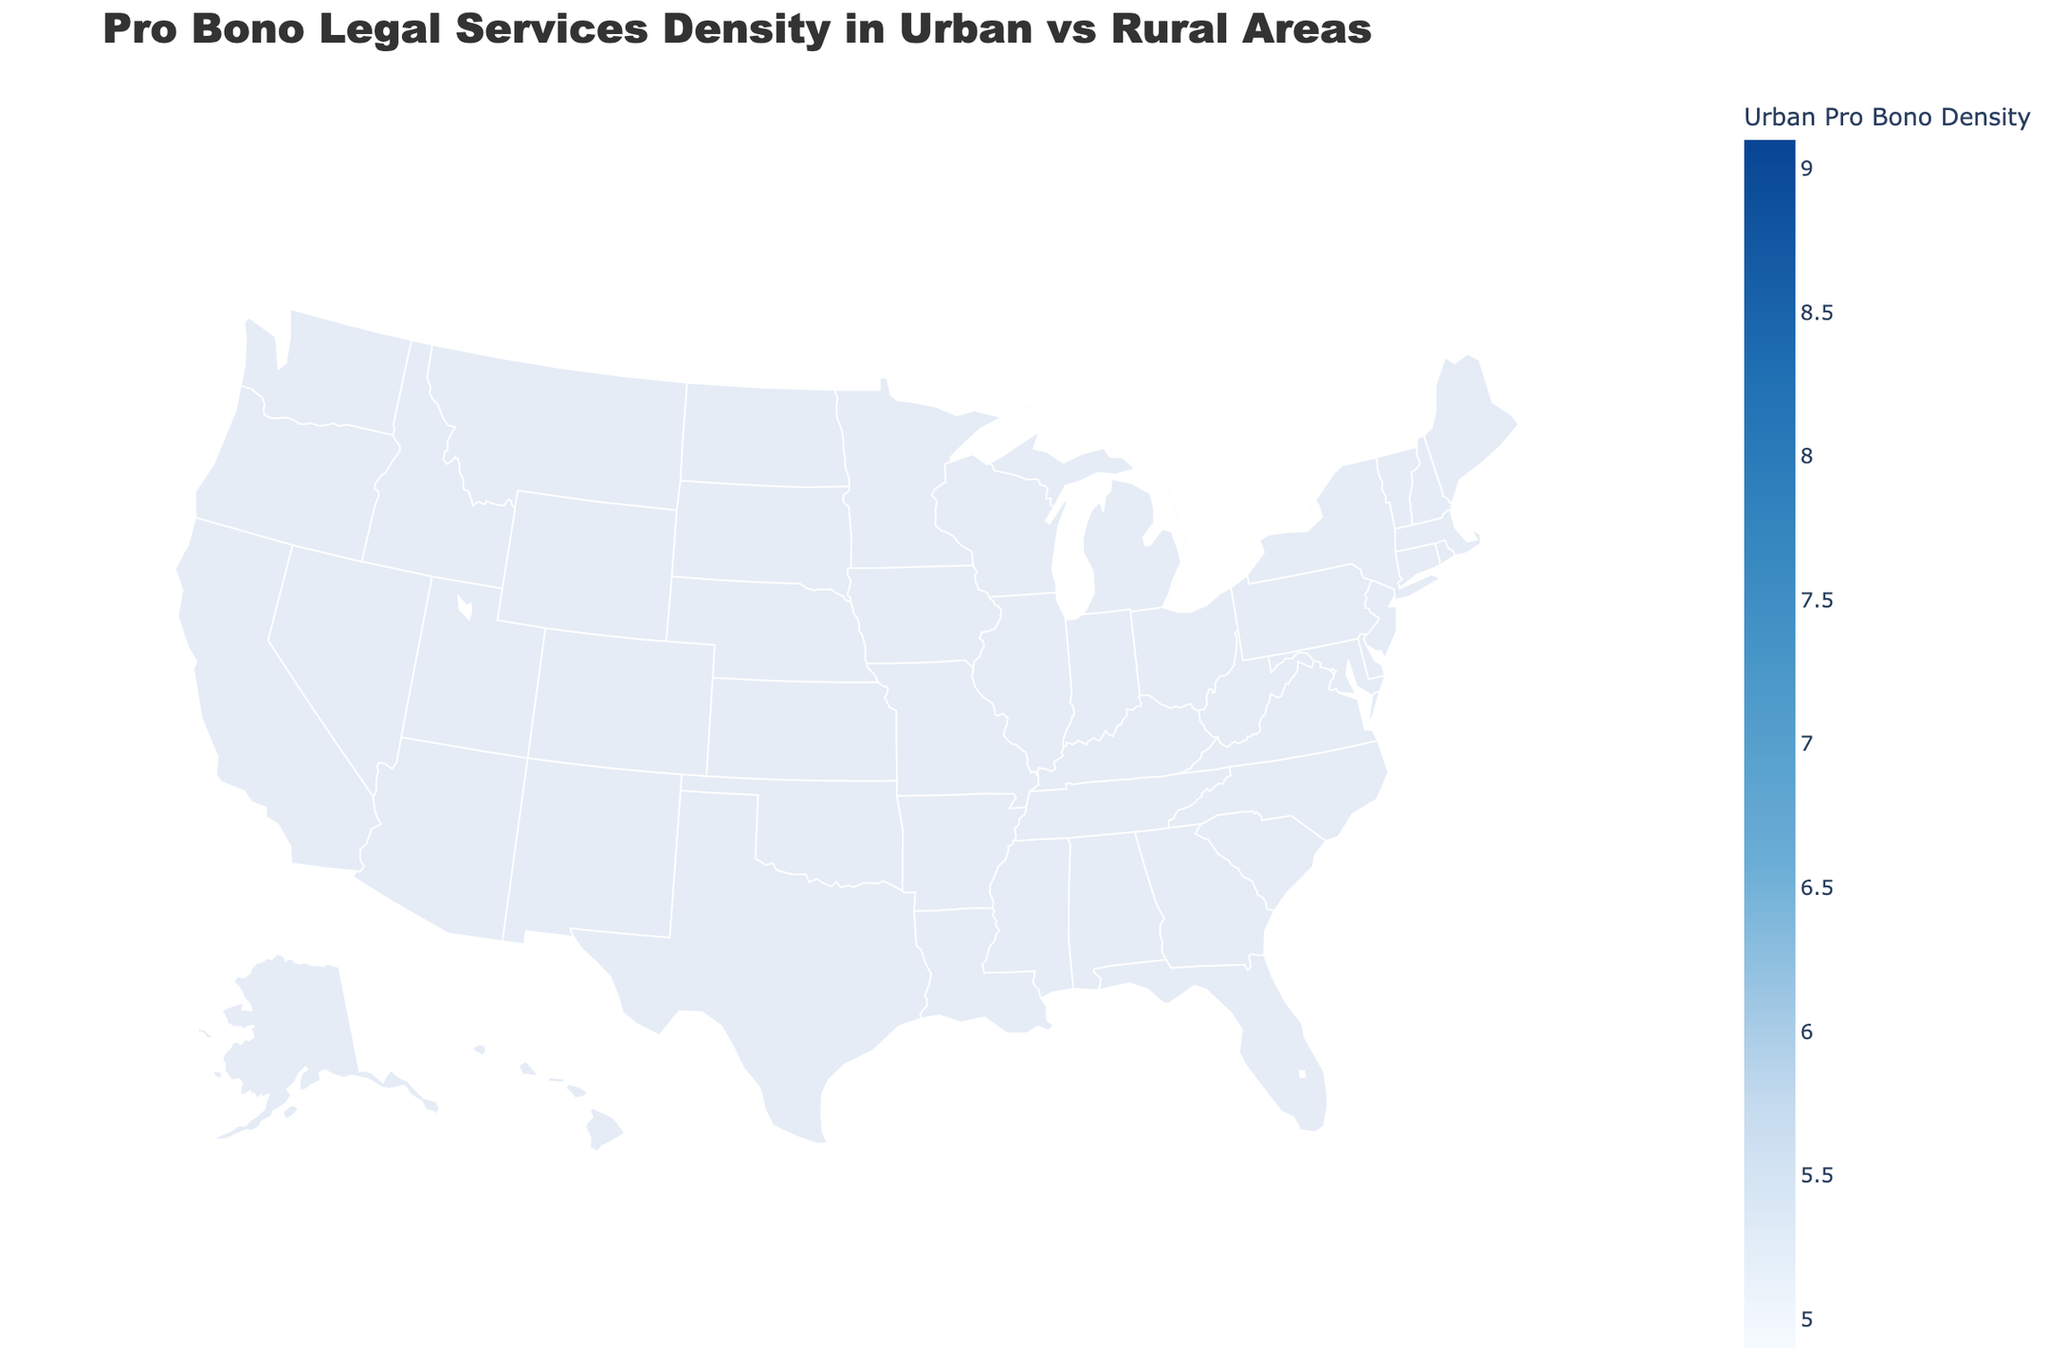What is the title of the figure? The title is prominently displayed at the top of the figure and should be easy to identify.
Answer: Pro Bono Legal Services Density in Urban vs Rural Areas Which state has the highest urban pro bono density? By examining the shades of color on the geographic plot, the darkest shade represents the highest urban pro bono density. Check for the state with this shade and refer to the data for confirmation.
Answer: New York Which state has the lowest rural pro bono density? Look for the state with the lightest shade of color or the one least prominent in the rural category in the hover text to identify the lowest density.
Answer: Georgia What is the urban pro bono density in Florida? Hover over the state of Florida on the map to see the detailed urban pro bono density.
Answer: 7.3 Compare the urban and rural pro bono densities in Massachusetts. What is the difference between them? Look at the hover text for Massachusetts, which shows "Urban: 8.5" and "Rural: 2.6". Subtract the rural value from the urban value (8.5 - 2.6).
Answer: 5.9 Which states have an urban pro bono density higher than 8? Identify the states where the color shade indicates an urban pro bono density higher than 8 and confirm by hovering over each state to check the exact values.
Answer: California, New York, Massachusetts What is the average urban pro bono density across all states? Sum the urban pro bono densities of all states and divide by the total number of states (18 in this case). Total is 111.6, so the average is 111.6/18.
Answer: 6.2 How does the urban pro bono density in Texas compare to its rural pro bono density? Hover over Texas and refer to the displayed values: Urban Pro Bono Density is 6.5 and Rural Pro Bono Density is 1.5. Compare these two values.
Answer: Urban density is higher by 5 What color represents states with the lowest urban pro bono density? Refer to the color scale and identify the color used for the lowest density category.
Answer: Light blue Which state has the smallest difference between urban and rural pro bono densities? Calculate the difference for each state by subtracting rural density from urban density, then find the state with the smallest value.
Answer: Indiana 